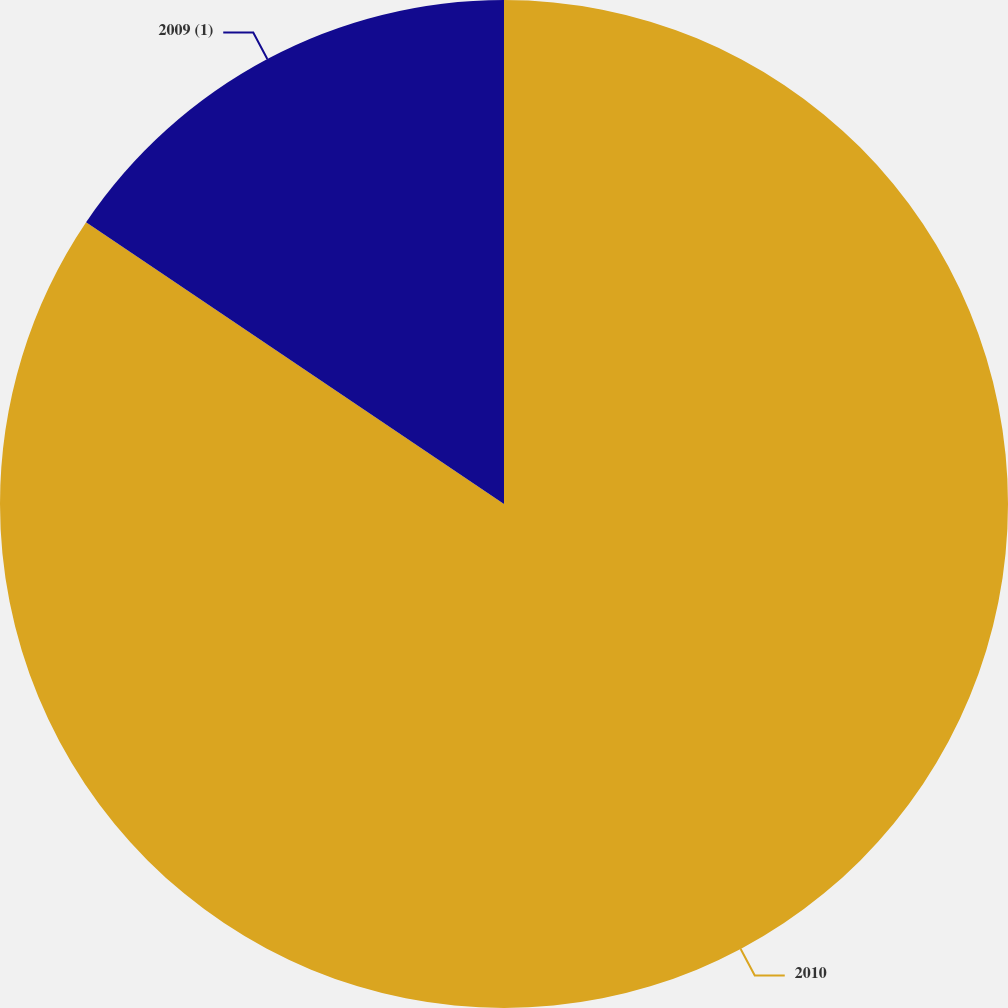Convert chart. <chart><loc_0><loc_0><loc_500><loc_500><pie_chart><fcel>2010<fcel>2009 (1)<nl><fcel>84.44%<fcel>15.56%<nl></chart> 